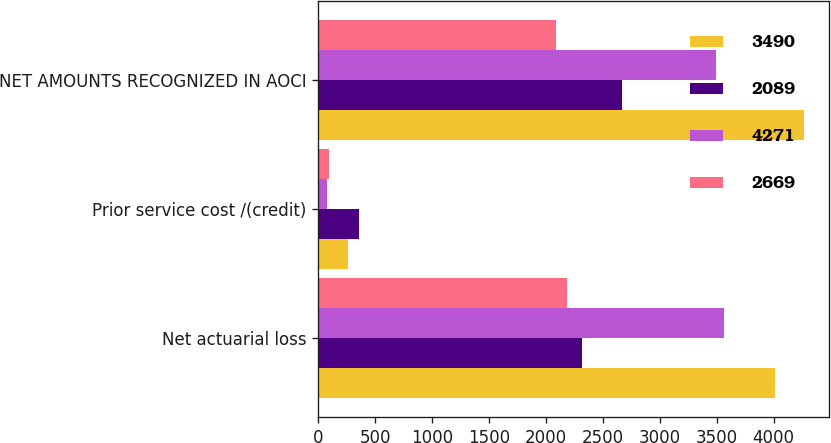Convert chart. <chart><loc_0><loc_0><loc_500><loc_500><stacked_bar_chart><ecel><fcel>Net actuarial loss<fcel>Prior service cost /(credit)<fcel>NET AMOUNTS RECOGNIZED IN AOCI<nl><fcel>3490<fcel>4010<fcel>261<fcel>4271<nl><fcel>2089<fcel>2315<fcel>354<fcel>2669<nl><fcel>4271<fcel>3565<fcel>75<fcel>3490<nl><fcel>2669<fcel>2181<fcel>92<fcel>2089<nl></chart> 